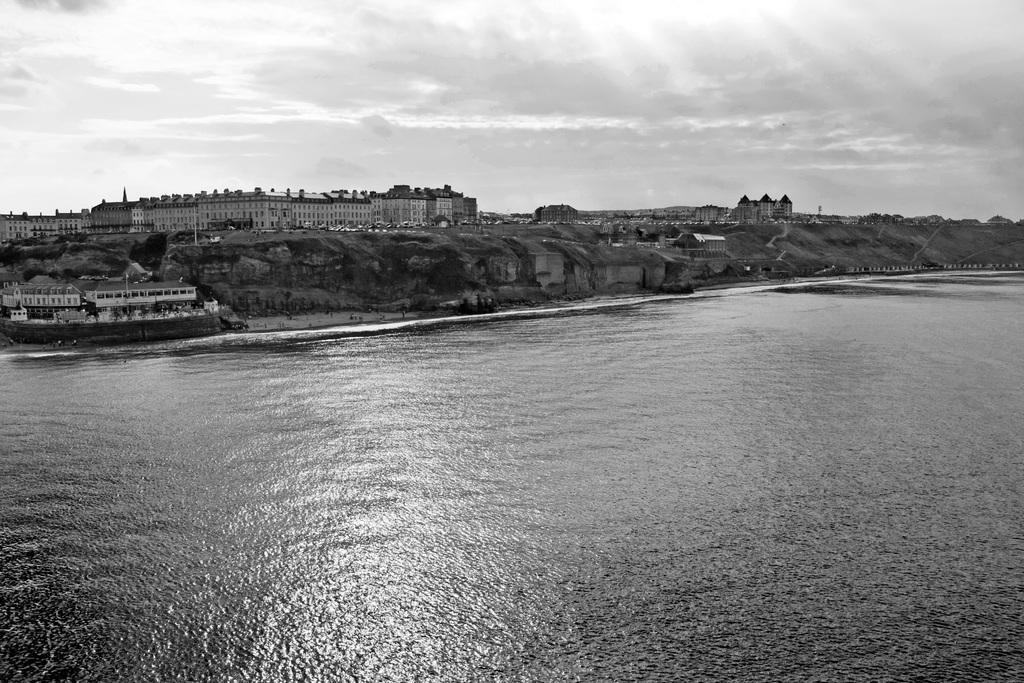What type of natural feature is present in the image? There is a river in the image. What structures are located near the river? There are buildings at the bank of the river in the image. What type of wood is used to support the houses in the image? There are no houses present in the image, only buildings. Additionally, the type of wood used for support is not mentioned or visible in the image. 